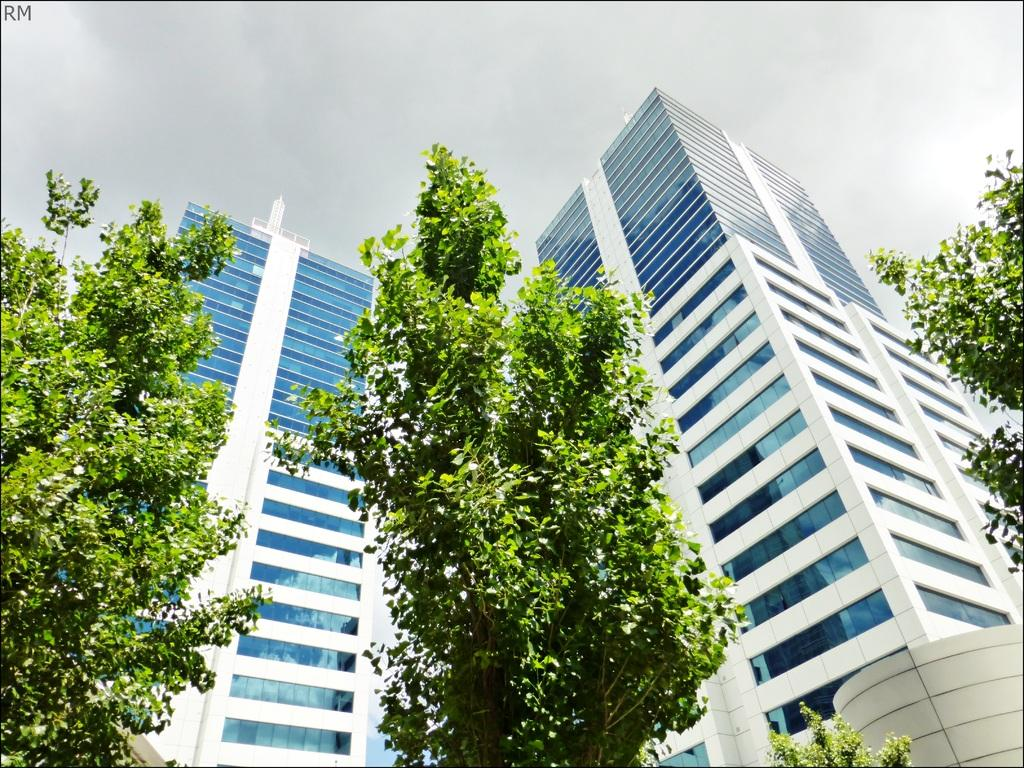What type of vegetation can be seen in the image? There are trees in the image. What type of man-made structures are present in the image? There are buildings in the image. How many toads can be seen sleeping on the buildings in the image? There are no toads present in the image, and therefore no such activity can be observed. What type of marble is visible on the ground in the image? There is no marble visible on the ground in the image. 